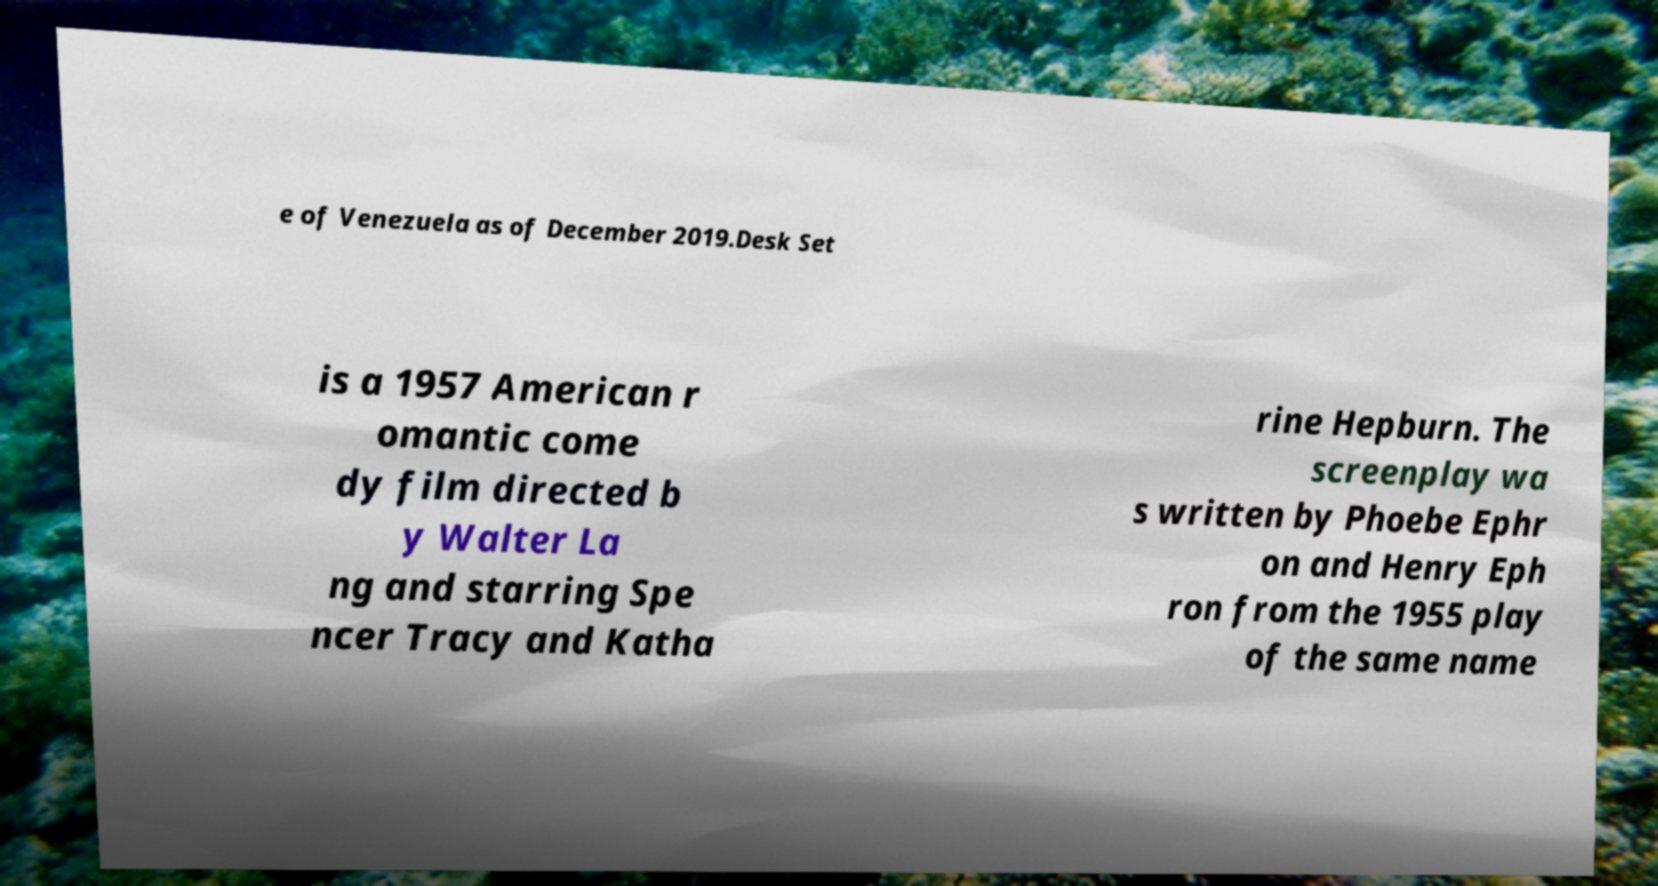Please read and relay the text visible in this image. What does it say? e of Venezuela as of December 2019.Desk Set is a 1957 American r omantic come dy film directed b y Walter La ng and starring Spe ncer Tracy and Katha rine Hepburn. The screenplay wa s written by Phoebe Ephr on and Henry Eph ron from the 1955 play of the same name 